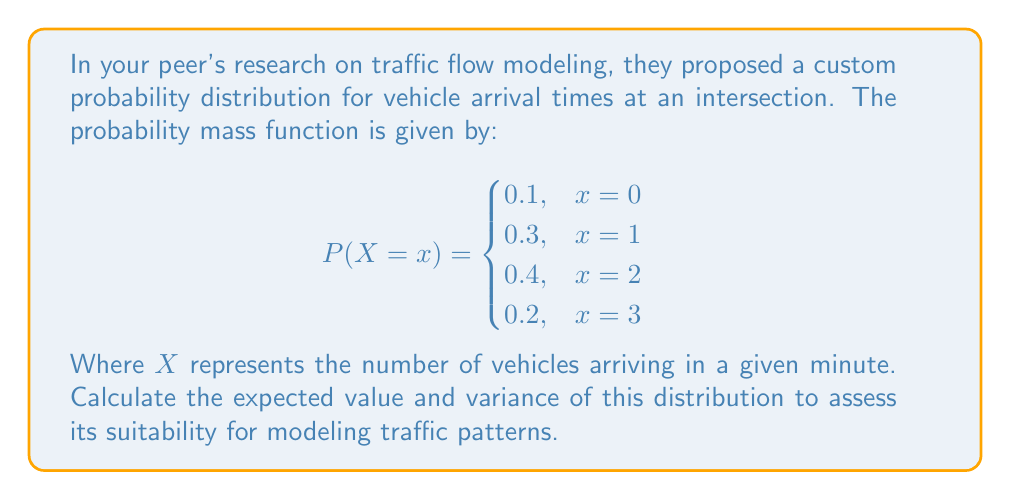Solve this math problem. To calculate the expected value and variance, we'll follow these steps:

1. Calculate the expected value $E(X)$:
   $$E(X) = \sum_{x} x \cdot P(X = x)$$
   $$E(X) = 0 \cdot 0.1 + 1 \cdot 0.3 + 2 \cdot 0.4 + 3 \cdot 0.2$$
   $$E(X) = 0 + 0.3 + 0.8 + 0.6 = 1.7$$

2. Calculate $E(X^2)$:
   $$E(X^2) = \sum_{x} x^2 \cdot P(X = x)$$
   $$E(X^2) = 0^2 \cdot 0.1 + 1^2 \cdot 0.3 + 2^2 \cdot 0.4 + 3^2 \cdot 0.2$$
   $$E(X^2) = 0 + 0.3 + 1.6 + 1.8 = 3.7$$

3. Calculate the variance $Var(X)$:
   $$Var(X) = E(X^2) - [E(X)]^2$$
   $$Var(X) = 3.7 - (1.7)^2$$
   $$Var(X) = 3.7 - 2.89 = 0.81$$

Therefore, the expected value is 1.7 and the variance is 0.81.
Answer: $E(X) = 1.7$, $Var(X) = 0.81$ 